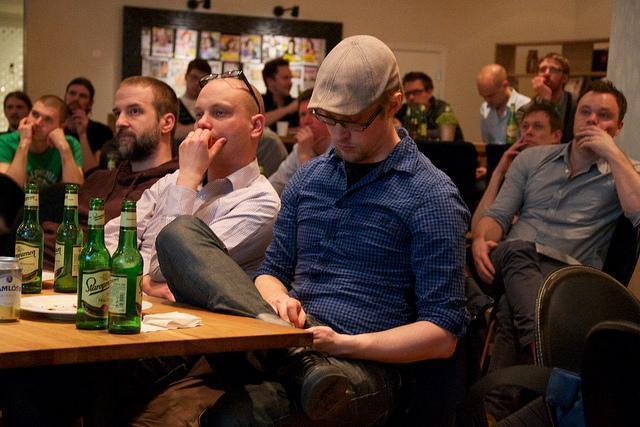How many people in this picture need to see an optometrist regularly?
Choose the right answer and clarify with the format: 'Answer: answer
Rationale: rationale.'
Options: Five, four, ten, thirteen. Answer: four.
Rationale: There's only a few people that wear eye glasses. 